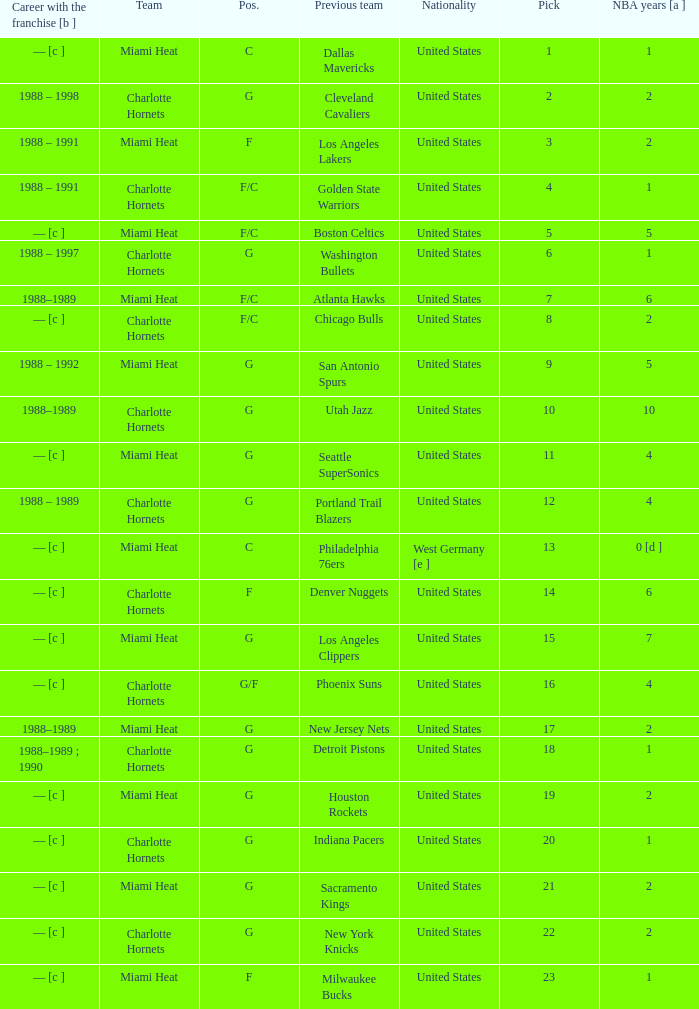What is the team of the player who was previously on the indiana pacers? Charlotte Hornets. 